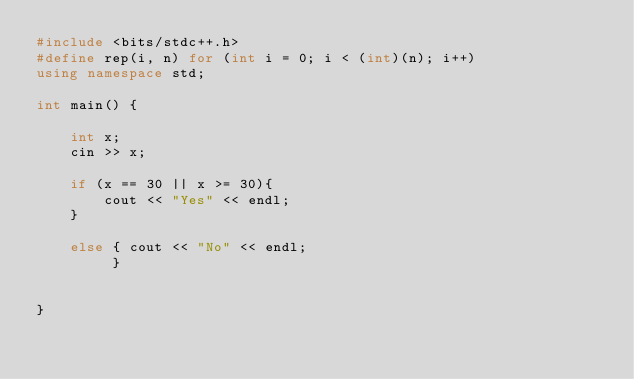Convert code to text. <code><loc_0><loc_0><loc_500><loc_500><_C++_>#include <bits/stdc++.h>
#define rep(i, n) for (int i = 0; i < (int)(n); i++)
using namespace std;

int main() {

    int x;
    cin >> x;
    
    if (x == 30 || x >= 30){
        cout << "Yes" << endl;
    }
    
    else { cout << "No" << endl;
         }
    
    
}</code> 